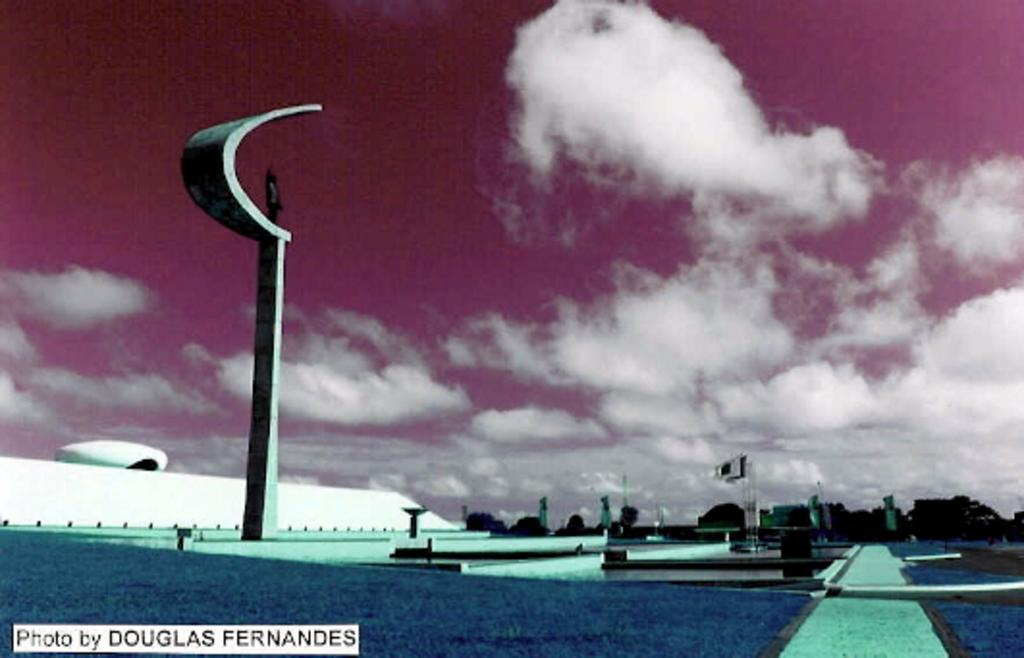What is the main structure in the image? There is a pole in the image. What artistic element can be seen in the image? There is a sculpture in the image. What national symbols are present in the image? There are flags in the image. What type of man-made structure is visible in the image? There is a building in the image. What type of natural elements are present in the image? There are trees in the image. What part of the natural environment is visible in the image? The sky is visible in the image. What type of authority figure can be seen in the image? There is no authority figure present in the image. What type of office furniture is visible in the image? There is no office furniture present in the image. 